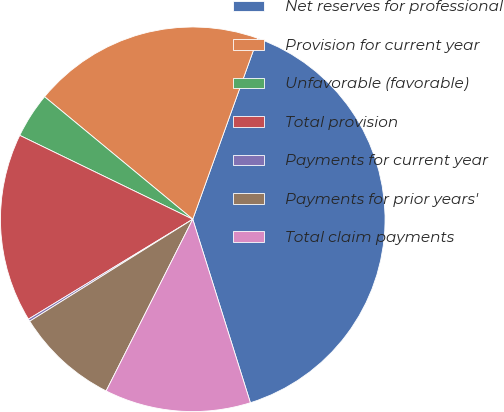Convert chart to OTSL. <chart><loc_0><loc_0><loc_500><loc_500><pie_chart><fcel>Net reserves for professional<fcel>Provision for current year<fcel>Unfavorable (favorable)<fcel>Total provision<fcel>Payments for current year<fcel>Payments for prior years'<fcel>Total claim payments<nl><fcel>39.67%<fcel>19.49%<fcel>3.81%<fcel>15.88%<fcel>0.2%<fcel>8.67%<fcel>12.28%<nl></chart> 